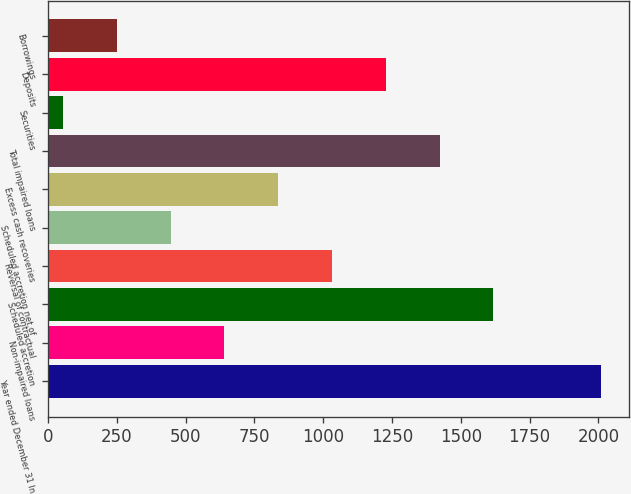Convert chart. <chart><loc_0><loc_0><loc_500><loc_500><bar_chart><fcel>Year ended December 31 In<fcel>Non-impaired loans<fcel>Scheduled accretion<fcel>Reversal of contractual<fcel>Scheduled accretion net of<fcel>Excess cash recoveries<fcel>Total impaired loans<fcel>Securities<fcel>Deposits<fcel>Borrowings<nl><fcel>2010<fcel>640.8<fcel>1618.8<fcel>1032<fcel>445.2<fcel>836.4<fcel>1423.2<fcel>54<fcel>1227.6<fcel>249.6<nl></chart> 